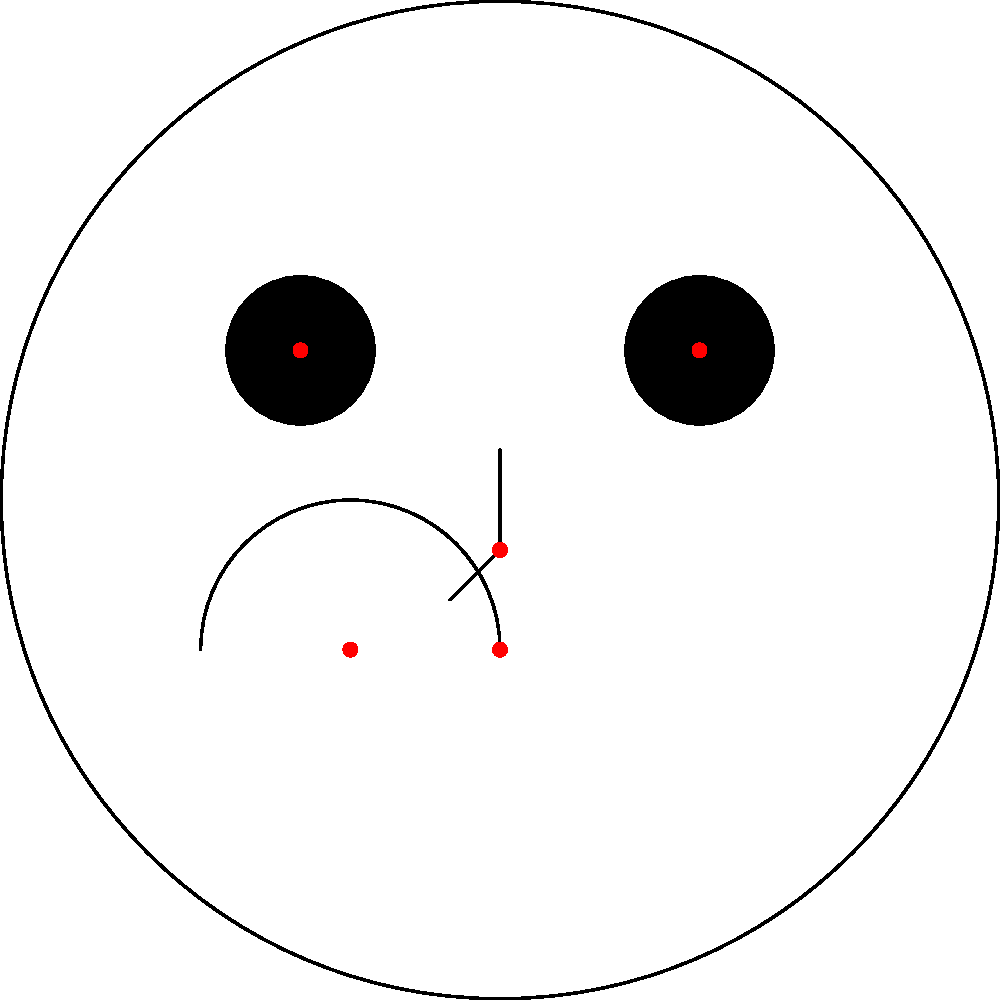In Android development, you're implementing facial feature detection using a pre-trained model. The model outputs coordinates for key facial landmarks as shown in the image. Which of the following approaches would be most efficient and accurate for determining if a person is smiling based on these landmarks?

A) Calculate the distance between the corners of the mouth
B) Measure the angle between the nose and mouth corners
C) Compare the y-coordinates of the mouth corners to a threshold
D) Analyze the curvature of the mouth line To determine if a person is smiling based on facial landmarks, we need to consider the most reliable and efficient method. Let's analyze each option:

1. Calculate the distance between the corners of the mouth:
   This method can be unreliable as mouth width varies between individuals and doesn't necessarily indicate a smile.

2. Measure the angle between the nose and mouth corners:
   While this could potentially indicate a smile, it's computationally more complex and may not be as reliable across different face shapes.

3. Compare the y-coordinates of the mouth corners to a threshold:
   This method is simple but doesn't account for the curvature of the smile, which is a key indicator.

4. Analyze the curvature of the mouth line:
   This is the most accurate and efficient approach for the following reasons:
   
   a) It directly relates to the definition of a smile (upward curvature of the mouth).
   b) It can be calculated using the three mouth landmarks (two corners and the center point).
   c) It's relatively invariant to face size and orientation.

To implement this:
1. Get the coordinates of the three mouth landmarks: $(x_1, y_1)$, $(x_2, y_2)$, and $(x_3, y_3)$.
2. Calculate the curvature using the formula:
   $$\kappa = \frac{4A}{pq r}$$
   where $A$ is the area of the triangle formed by the three points, $p$, $q$, and $r$ are the side lengths of the triangle.
3. If the curvature is positive and above a certain threshold, classify it as a smile.

This method provides a balance between accuracy and computational efficiency, making it suitable for real-time processing on Android devices.
Answer: Analyze the curvature of the mouth line 